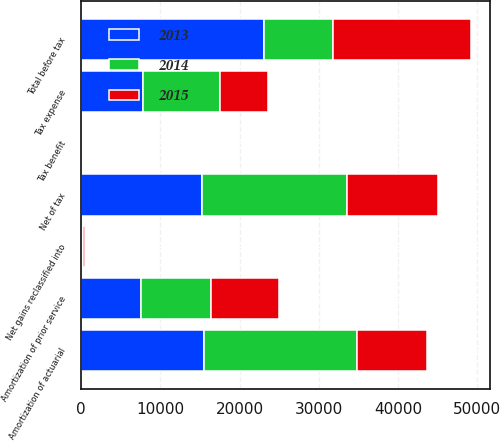<chart> <loc_0><loc_0><loc_500><loc_500><stacked_bar_chart><ecel><fcel>Amortization of actuarial<fcel>Amortization of prior service<fcel>Total before tax<fcel>Tax expense<fcel>Net of tax<fcel>Net gains reclassified into<fcel>Tax benefit<nl><fcel>2013<fcel>15527<fcel>7541<fcel>23068<fcel>7768<fcel>15300<fcel>166<fcel>58<nl><fcel>2015<fcel>8822<fcel>8556<fcel>17378<fcel>5969<fcel>11409<fcel>164<fcel>57<nl><fcel>2014<fcel>19250<fcel>8834<fcel>8689<fcel>9809<fcel>18275<fcel>130<fcel>46<nl></chart> 